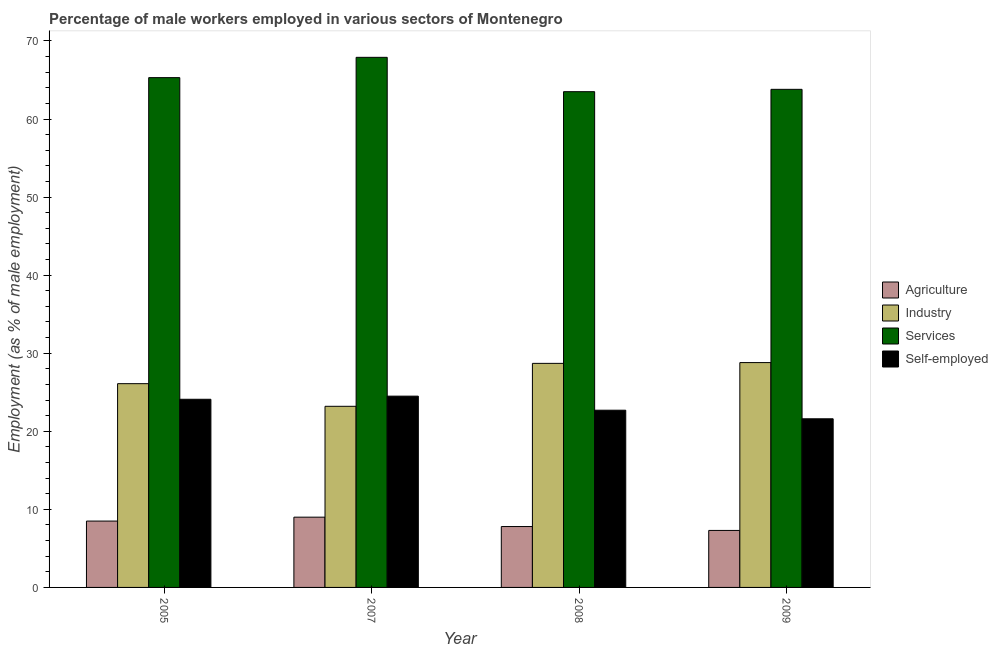How many different coloured bars are there?
Offer a very short reply. 4. How many groups of bars are there?
Offer a very short reply. 4. Are the number of bars on each tick of the X-axis equal?
Ensure brevity in your answer.  Yes. How many bars are there on the 3rd tick from the left?
Provide a short and direct response. 4. How many bars are there on the 4th tick from the right?
Make the answer very short. 4. What is the percentage of male workers in agriculture in 2009?
Provide a short and direct response. 7.3. Across all years, what is the maximum percentage of self employed male workers?
Keep it short and to the point. 24.5. Across all years, what is the minimum percentage of male workers in services?
Provide a succinct answer. 63.5. In which year was the percentage of male workers in agriculture maximum?
Your answer should be compact. 2007. What is the total percentage of self employed male workers in the graph?
Your response must be concise. 92.9. What is the difference between the percentage of self employed male workers in 2008 and that in 2009?
Give a very brief answer. 1.1. What is the average percentage of male workers in agriculture per year?
Your response must be concise. 8.15. In how many years, is the percentage of male workers in agriculture greater than 30 %?
Provide a succinct answer. 0. What is the ratio of the percentage of male workers in industry in 2008 to that in 2009?
Offer a terse response. 1. Is the difference between the percentage of self employed male workers in 2007 and 2008 greater than the difference between the percentage of male workers in agriculture in 2007 and 2008?
Your answer should be very brief. No. What is the difference between the highest and the second highest percentage of self employed male workers?
Provide a succinct answer. 0.4. What is the difference between the highest and the lowest percentage of male workers in services?
Provide a succinct answer. 4.4. In how many years, is the percentage of male workers in industry greater than the average percentage of male workers in industry taken over all years?
Your answer should be compact. 2. Is the sum of the percentage of male workers in agriculture in 2005 and 2009 greater than the maximum percentage of male workers in services across all years?
Give a very brief answer. Yes. What does the 2nd bar from the left in 2005 represents?
Provide a short and direct response. Industry. What does the 1st bar from the right in 2005 represents?
Ensure brevity in your answer.  Self-employed. How many years are there in the graph?
Offer a very short reply. 4. What is the difference between two consecutive major ticks on the Y-axis?
Your answer should be compact. 10. How are the legend labels stacked?
Provide a short and direct response. Vertical. What is the title of the graph?
Give a very brief answer. Percentage of male workers employed in various sectors of Montenegro. Does "Gender equality" appear as one of the legend labels in the graph?
Provide a succinct answer. No. What is the label or title of the Y-axis?
Keep it short and to the point. Employment (as % of male employment). What is the Employment (as % of male employment) in Industry in 2005?
Your answer should be very brief. 26.1. What is the Employment (as % of male employment) of Services in 2005?
Ensure brevity in your answer.  65.3. What is the Employment (as % of male employment) in Self-employed in 2005?
Provide a short and direct response. 24.1. What is the Employment (as % of male employment) of Agriculture in 2007?
Give a very brief answer. 9. What is the Employment (as % of male employment) of Industry in 2007?
Give a very brief answer. 23.2. What is the Employment (as % of male employment) of Services in 2007?
Provide a succinct answer. 67.9. What is the Employment (as % of male employment) of Self-employed in 2007?
Give a very brief answer. 24.5. What is the Employment (as % of male employment) of Agriculture in 2008?
Your answer should be very brief. 7.8. What is the Employment (as % of male employment) of Industry in 2008?
Keep it short and to the point. 28.7. What is the Employment (as % of male employment) in Services in 2008?
Keep it short and to the point. 63.5. What is the Employment (as % of male employment) of Self-employed in 2008?
Ensure brevity in your answer.  22.7. What is the Employment (as % of male employment) in Agriculture in 2009?
Offer a very short reply. 7.3. What is the Employment (as % of male employment) in Industry in 2009?
Your answer should be very brief. 28.8. What is the Employment (as % of male employment) of Services in 2009?
Offer a very short reply. 63.8. What is the Employment (as % of male employment) in Self-employed in 2009?
Provide a short and direct response. 21.6. Across all years, what is the maximum Employment (as % of male employment) in Industry?
Your answer should be compact. 28.8. Across all years, what is the maximum Employment (as % of male employment) in Services?
Your answer should be compact. 67.9. Across all years, what is the minimum Employment (as % of male employment) in Agriculture?
Ensure brevity in your answer.  7.3. Across all years, what is the minimum Employment (as % of male employment) of Industry?
Offer a very short reply. 23.2. Across all years, what is the minimum Employment (as % of male employment) in Services?
Your response must be concise. 63.5. Across all years, what is the minimum Employment (as % of male employment) in Self-employed?
Offer a terse response. 21.6. What is the total Employment (as % of male employment) of Agriculture in the graph?
Give a very brief answer. 32.6. What is the total Employment (as % of male employment) of Industry in the graph?
Offer a very short reply. 106.8. What is the total Employment (as % of male employment) in Services in the graph?
Give a very brief answer. 260.5. What is the total Employment (as % of male employment) in Self-employed in the graph?
Keep it short and to the point. 92.9. What is the difference between the Employment (as % of male employment) in Agriculture in 2005 and that in 2007?
Offer a very short reply. -0.5. What is the difference between the Employment (as % of male employment) in Industry in 2005 and that in 2007?
Give a very brief answer. 2.9. What is the difference between the Employment (as % of male employment) of Agriculture in 2005 and that in 2008?
Provide a succinct answer. 0.7. What is the difference between the Employment (as % of male employment) in Agriculture in 2005 and that in 2009?
Your answer should be very brief. 1.2. What is the difference between the Employment (as % of male employment) in Industry in 2005 and that in 2009?
Ensure brevity in your answer.  -2.7. What is the difference between the Employment (as % of male employment) of Services in 2005 and that in 2009?
Offer a terse response. 1.5. What is the difference between the Employment (as % of male employment) of Services in 2007 and that in 2008?
Provide a short and direct response. 4.4. What is the difference between the Employment (as % of male employment) in Industry in 2007 and that in 2009?
Your answer should be very brief. -5.6. What is the difference between the Employment (as % of male employment) in Agriculture in 2008 and that in 2009?
Provide a succinct answer. 0.5. What is the difference between the Employment (as % of male employment) in Industry in 2008 and that in 2009?
Provide a short and direct response. -0.1. What is the difference between the Employment (as % of male employment) in Services in 2008 and that in 2009?
Your answer should be compact. -0.3. What is the difference between the Employment (as % of male employment) of Agriculture in 2005 and the Employment (as % of male employment) of Industry in 2007?
Your answer should be compact. -14.7. What is the difference between the Employment (as % of male employment) of Agriculture in 2005 and the Employment (as % of male employment) of Services in 2007?
Your answer should be compact. -59.4. What is the difference between the Employment (as % of male employment) in Agriculture in 2005 and the Employment (as % of male employment) in Self-employed in 2007?
Offer a very short reply. -16. What is the difference between the Employment (as % of male employment) in Industry in 2005 and the Employment (as % of male employment) in Services in 2007?
Your answer should be compact. -41.8. What is the difference between the Employment (as % of male employment) in Services in 2005 and the Employment (as % of male employment) in Self-employed in 2007?
Offer a terse response. 40.8. What is the difference between the Employment (as % of male employment) of Agriculture in 2005 and the Employment (as % of male employment) of Industry in 2008?
Offer a very short reply. -20.2. What is the difference between the Employment (as % of male employment) of Agriculture in 2005 and the Employment (as % of male employment) of Services in 2008?
Provide a short and direct response. -55. What is the difference between the Employment (as % of male employment) of Agriculture in 2005 and the Employment (as % of male employment) of Self-employed in 2008?
Provide a succinct answer. -14.2. What is the difference between the Employment (as % of male employment) of Industry in 2005 and the Employment (as % of male employment) of Services in 2008?
Your answer should be very brief. -37.4. What is the difference between the Employment (as % of male employment) in Industry in 2005 and the Employment (as % of male employment) in Self-employed in 2008?
Offer a very short reply. 3.4. What is the difference between the Employment (as % of male employment) of Services in 2005 and the Employment (as % of male employment) of Self-employed in 2008?
Provide a short and direct response. 42.6. What is the difference between the Employment (as % of male employment) of Agriculture in 2005 and the Employment (as % of male employment) of Industry in 2009?
Your answer should be compact. -20.3. What is the difference between the Employment (as % of male employment) of Agriculture in 2005 and the Employment (as % of male employment) of Services in 2009?
Provide a short and direct response. -55.3. What is the difference between the Employment (as % of male employment) of Industry in 2005 and the Employment (as % of male employment) of Services in 2009?
Ensure brevity in your answer.  -37.7. What is the difference between the Employment (as % of male employment) in Services in 2005 and the Employment (as % of male employment) in Self-employed in 2009?
Ensure brevity in your answer.  43.7. What is the difference between the Employment (as % of male employment) of Agriculture in 2007 and the Employment (as % of male employment) of Industry in 2008?
Provide a short and direct response. -19.7. What is the difference between the Employment (as % of male employment) of Agriculture in 2007 and the Employment (as % of male employment) of Services in 2008?
Provide a succinct answer. -54.5. What is the difference between the Employment (as % of male employment) of Agriculture in 2007 and the Employment (as % of male employment) of Self-employed in 2008?
Provide a short and direct response. -13.7. What is the difference between the Employment (as % of male employment) in Industry in 2007 and the Employment (as % of male employment) in Services in 2008?
Ensure brevity in your answer.  -40.3. What is the difference between the Employment (as % of male employment) of Services in 2007 and the Employment (as % of male employment) of Self-employed in 2008?
Provide a short and direct response. 45.2. What is the difference between the Employment (as % of male employment) of Agriculture in 2007 and the Employment (as % of male employment) of Industry in 2009?
Your answer should be very brief. -19.8. What is the difference between the Employment (as % of male employment) of Agriculture in 2007 and the Employment (as % of male employment) of Services in 2009?
Offer a very short reply. -54.8. What is the difference between the Employment (as % of male employment) of Industry in 2007 and the Employment (as % of male employment) of Services in 2009?
Give a very brief answer. -40.6. What is the difference between the Employment (as % of male employment) of Services in 2007 and the Employment (as % of male employment) of Self-employed in 2009?
Offer a very short reply. 46.3. What is the difference between the Employment (as % of male employment) of Agriculture in 2008 and the Employment (as % of male employment) of Industry in 2009?
Give a very brief answer. -21. What is the difference between the Employment (as % of male employment) of Agriculture in 2008 and the Employment (as % of male employment) of Services in 2009?
Offer a very short reply. -56. What is the difference between the Employment (as % of male employment) of Agriculture in 2008 and the Employment (as % of male employment) of Self-employed in 2009?
Your answer should be very brief. -13.8. What is the difference between the Employment (as % of male employment) of Industry in 2008 and the Employment (as % of male employment) of Services in 2009?
Your response must be concise. -35.1. What is the difference between the Employment (as % of male employment) in Services in 2008 and the Employment (as % of male employment) in Self-employed in 2009?
Your answer should be very brief. 41.9. What is the average Employment (as % of male employment) of Agriculture per year?
Keep it short and to the point. 8.15. What is the average Employment (as % of male employment) of Industry per year?
Your response must be concise. 26.7. What is the average Employment (as % of male employment) in Services per year?
Your answer should be compact. 65.12. What is the average Employment (as % of male employment) of Self-employed per year?
Give a very brief answer. 23.23. In the year 2005, what is the difference between the Employment (as % of male employment) of Agriculture and Employment (as % of male employment) of Industry?
Keep it short and to the point. -17.6. In the year 2005, what is the difference between the Employment (as % of male employment) of Agriculture and Employment (as % of male employment) of Services?
Ensure brevity in your answer.  -56.8. In the year 2005, what is the difference between the Employment (as % of male employment) in Agriculture and Employment (as % of male employment) in Self-employed?
Your answer should be very brief. -15.6. In the year 2005, what is the difference between the Employment (as % of male employment) in Industry and Employment (as % of male employment) in Services?
Ensure brevity in your answer.  -39.2. In the year 2005, what is the difference between the Employment (as % of male employment) of Industry and Employment (as % of male employment) of Self-employed?
Ensure brevity in your answer.  2. In the year 2005, what is the difference between the Employment (as % of male employment) in Services and Employment (as % of male employment) in Self-employed?
Your answer should be very brief. 41.2. In the year 2007, what is the difference between the Employment (as % of male employment) of Agriculture and Employment (as % of male employment) of Industry?
Your response must be concise. -14.2. In the year 2007, what is the difference between the Employment (as % of male employment) in Agriculture and Employment (as % of male employment) in Services?
Provide a short and direct response. -58.9. In the year 2007, what is the difference between the Employment (as % of male employment) in Agriculture and Employment (as % of male employment) in Self-employed?
Provide a short and direct response. -15.5. In the year 2007, what is the difference between the Employment (as % of male employment) of Industry and Employment (as % of male employment) of Services?
Give a very brief answer. -44.7. In the year 2007, what is the difference between the Employment (as % of male employment) in Services and Employment (as % of male employment) in Self-employed?
Ensure brevity in your answer.  43.4. In the year 2008, what is the difference between the Employment (as % of male employment) of Agriculture and Employment (as % of male employment) of Industry?
Make the answer very short. -20.9. In the year 2008, what is the difference between the Employment (as % of male employment) in Agriculture and Employment (as % of male employment) in Services?
Give a very brief answer. -55.7. In the year 2008, what is the difference between the Employment (as % of male employment) of Agriculture and Employment (as % of male employment) of Self-employed?
Ensure brevity in your answer.  -14.9. In the year 2008, what is the difference between the Employment (as % of male employment) in Industry and Employment (as % of male employment) in Services?
Provide a short and direct response. -34.8. In the year 2008, what is the difference between the Employment (as % of male employment) of Services and Employment (as % of male employment) of Self-employed?
Keep it short and to the point. 40.8. In the year 2009, what is the difference between the Employment (as % of male employment) of Agriculture and Employment (as % of male employment) of Industry?
Keep it short and to the point. -21.5. In the year 2009, what is the difference between the Employment (as % of male employment) in Agriculture and Employment (as % of male employment) in Services?
Make the answer very short. -56.5. In the year 2009, what is the difference between the Employment (as % of male employment) of Agriculture and Employment (as % of male employment) of Self-employed?
Ensure brevity in your answer.  -14.3. In the year 2009, what is the difference between the Employment (as % of male employment) of Industry and Employment (as % of male employment) of Services?
Keep it short and to the point. -35. In the year 2009, what is the difference between the Employment (as % of male employment) of Industry and Employment (as % of male employment) of Self-employed?
Keep it short and to the point. 7.2. In the year 2009, what is the difference between the Employment (as % of male employment) of Services and Employment (as % of male employment) of Self-employed?
Offer a very short reply. 42.2. What is the ratio of the Employment (as % of male employment) of Agriculture in 2005 to that in 2007?
Provide a succinct answer. 0.94. What is the ratio of the Employment (as % of male employment) in Industry in 2005 to that in 2007?
Your answer should be compact. 1.12. What is the ratio of the Employment (as % of male employment) of Services in 2005 to that in 2007?
Offer a terse response. 0.96. What is the ratio of the Employment (as % of male employment) in Self-employed in 2005 to that in 2007?
Offer a very short reply. 0.98. What is the ratio of the Employment (as % of male employment) of Agriculture in 2005 to that in 2008?
Your answer should be very brief. 1.09. What is the ratio of the Employment (as % of male employment) in Industry in 2005 to that in 2008?
Your answer should be very brief. 0.91. What is the ratio of the Employment (as % of male employment) of Services in 2005 to that in 2008?
Offer a terse response. 1.03. What is the ratio of the Employment (as % of male employment) in Self-employed in 2005 to that in 2008?
Provide a succinct answer. 1.06. What is the ratio of the Employment (as % of male employment) of Agriculture in 2005 to that in 2009?
Your response must be concise. 1.16. What is the ratio of the Employment (as % of male employment) of Industry in 2005 to that in 2009?
Offer a terse response. 0.91. What is the ratio of the Employment (as % of male employment) in Services in 2005 to that in 2009?
Your response must be concise. 1.02. What is the ratio of the Employment (as % of male employment) in Self-employed in 2005 to that in 2009?
Provide a succinct answer. 1.12. What is the ratio of the Employment (as % of male employment) of Agriculture in 2007 to that in 2008?
Ensure brevity in your answer.  1.15. What is the ratio of the Employment (as % of male employment) of Industry in 2007 to that in 2008?
Offer a terse response. 0.81. What is the ratio of the Employment (as % of male employment) in Services in 2007 to that in 2008?
Ensure brevity in your answer.  1.07. What is the ratio of the Employment (as % of male employment) of Self-employed in 2007 to that in 2008?
Your answer should be very brief. 1.08. What is the ratio of the Employment (as % of male employment) of Agriculture in 2007 to that in 2009?
Make the answer very short. 1.23. What is the ratio of the Employment (as % of male employment) of Industry in 2007 to that in 2009?
Ensure brevity in your answer.  0.81. What is the ratio of the Employment (as % of male employment) of Services in 2007 to that in 2009?
Offer a very short reply. 1.06. What is the ratio of the Employment (as % of male employment) of Self-employed in 2007 to that in 2009?
Your response must be concise. 1.13. What is the ratio of the Employment (as % of male employment) in Agriculture in 2008 to that in 2009?
Give a very brief answer. 1.07. What is the ratio of the Employment (as % of male employment) of Self-employed in 2008 to that in 2009?
Give a very brief answer. 1.05. What is the difference between the highest and the second highest Employment (as % of male employment) in Agriculture?
Keep it short and to the point. 0.5. What is the difference between the highest and the second highest Employment (as % of male employment) in Industry?
Your response must be concise. 0.1. What is the difference between the highest and the second highest Employment (as % of male employment) in Services?
Offer a very short reply. 2.6. What is the difference between the highest and the second highest Employment (as % of male employment) in Self-employed?
Keep it short and to the point. 0.4. What is the difference between the highest and the lowest Employment (as % of male employment) in Industry?
Make the answer very short. 5.6. 